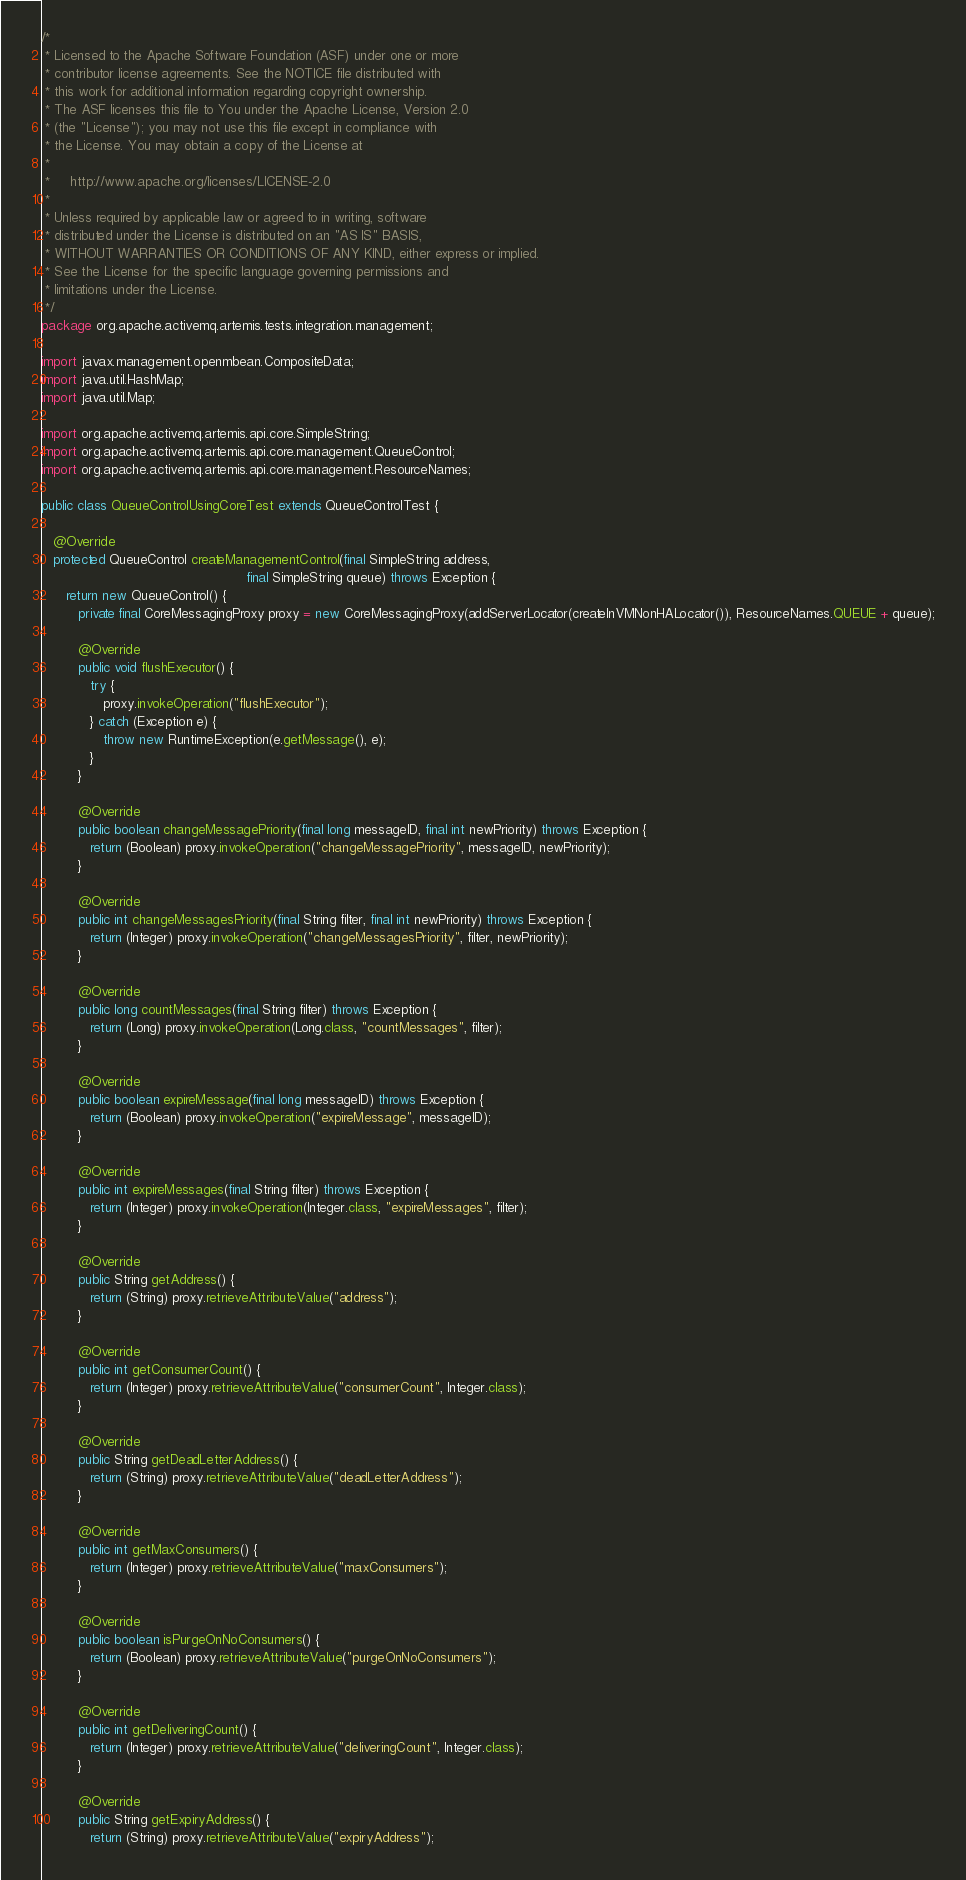Convert code to text. <code><loc_0><loc_0><loc_500><loc_500><_Java_>/*
 * Licensed to the Apache Software Foundation (ASF) under one or more
 * contributor license agreements. See the NOTICE file distributed with
 * this work for additional information regarding copyright ownership.
 * The ASF licenses this file to You under the Apache License, Version 2.0
 * (the "License"); you may not use this file except in compliance with
 * the License. You may obtain a copy of the License at
 *
 *     http://www.apache.org/licenses/LICENSE-2.0
 *
 * Unless required by applicable law or agreed to in writing, software
 * distributed under the License is distributed on an "AS IS" BASIS,
 * WITHOUT WARRANTIES OR CONDITIONS OF ANY KIND, either express or implied.
 * See the License for the specific language governing permissions and
 * limitations under the License.
 */
package org.apache.activemq.artemis.tests.integration.management;

import javax.management.openmbean.CompositeData;
import java.util.HashMap;
import java.util.Map;

import org.apache.activemq.artemis.api.core.SimpleString;
import org.apache.activemq.artemis.api.core.management.QueueControl;
import org.apache.activemq.artemis.api.core.management.ResourceNames;

public class QueueControlUsingCoreTest extends QueueControlTest {

   @Override
   protected QueueControl createManagementControl(final SimpleString address,
                                                  final SimpleString queue) throws Exception {
      return new QueueControl() {
         private final CoreMessagingProxy proxy = new CoreMessagingProxy(addServerLocator(createInVMNonHALocator()), ResourceNames.QUEUE + queue);

         @Override
         public void flushExecutor() {
            try {
               proxy.invokeOperation("flushExecutor");
            } catch (Exception e) {
               throw new RuntimeException(e.getMessage(), e);
            }
         }

         @Override
         public boolean changeMessagePriority(final long messageID, final int newPriority) throws Exception {
            return (Boolean) proxy.invokeOperation("changeMessagePriority", messageID, newPriority);
         }

         @Override
         public int changeMessagesPriority(final String filter, final int newPriority) throws Exception {
            return (Integer) proxy.invokeOperation("changeMessagesPriority", filter, newPriority);
         }

         @Override
         public long countMessages(final String filter) throws Exception {
            return (Long) proxy.invokeOperation(Long.class, "countMessages", filter);
         }

         @Override
         public boolean expireMessage(final long messageID) throws Exception {
            return (Boolean) proxy.invokeOperation("expireMessage", messageID);
         }

         @Override
         public int expireMessages(final String filter) throws Exception {
            return (Integer) proxy.invokeOperation(Integer.class, "expireMessages", filter);
         }

         @Override
         public String getAddress() {
            return (String) proxy.retrieveAttributeValue("address");
         }

         @Override
         public int getConsumerCount() {
            return (Integer) proxy.retrieveAttributeValue("consumerCount", Integer.class);
         }

         @Override
         public String getDeadLetterAddress() {
            return (String) proxy.retrieveAttributeValue("deadLetterAddress");
         }

         @Override
         public int getMaxConsumers() {
            return (Integer) proxy.retrieveAttributeValue("maxConsumers");
         }

         @Override
         public boolean isPurgeOnNoConsumers() {
            return (Boolean) proxy.retrieveAttributeValue("purgeOnNoConsumers");
         }

         @Override
         public int getDeliveringCount() {
            return (Integer) proxy.retrieveAttributeValue("deliveringCount", Integer.class);
         }

         @Override
         public String getExpiryAddress() {
            return (String) proxy.retrieveAttributeValue("expiryAddress");</code> 